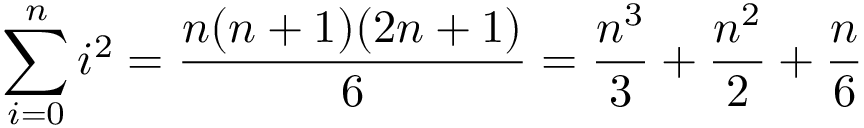<formula> <loc_0><loc_0><loc_500><loc_500>\sum _ { i = 0 } ^ { n } i ^ { 2 } = { \frac { n ( n + 1 ) ( 2 n + 1 ) } { 6 } } = { \frac { n ^ { 3 } } { 3 } } + { \frac { n ^ { 2 } } { 2 } } + { \frac { n } { 6 } }</formula> 